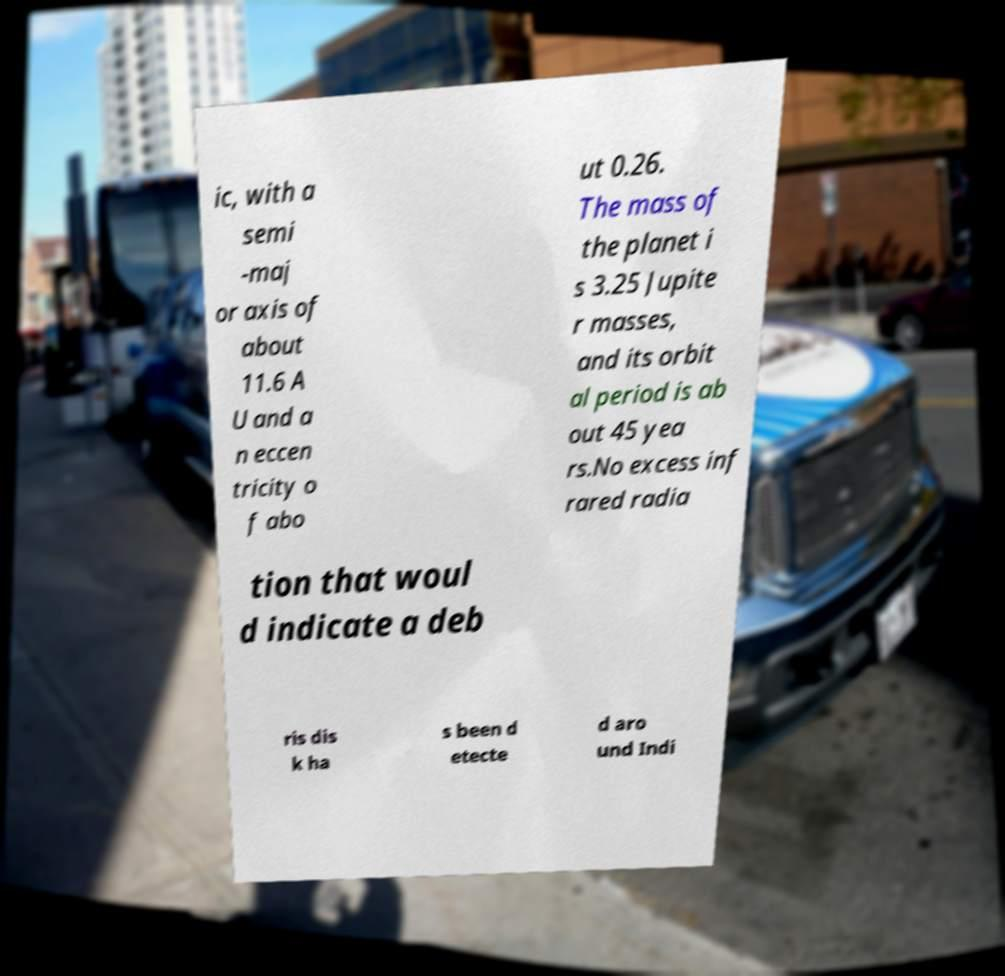There's text embedded in this image that I need extracted. Can you transcribe it verbatim? ic, with a semi -maj or axis of about 11.6 A U and a n eccen tricity o f abo ut 0.26. The mass of the planet i s 3.25 Jupite r masses, and its orbit al period is ab out 45 yea rs.No excess inf rared radia tion that woul d indicate a deb ris dis k ha s been d etecte d aro und Indi 